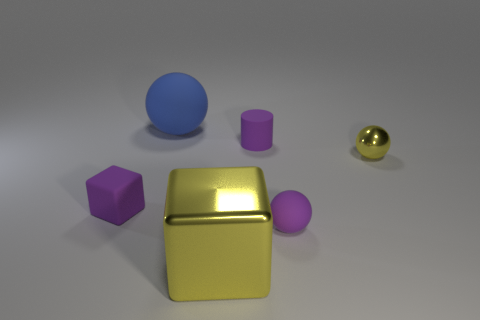Add 2 yellow things. How many objects exist? 8 Subtract all blocks. How many objects are left? 4 Subtract 0 green cubes. How many objects are left? 6 Subtract all small blue shiny objects. Subtract all small yellow metallic objects. How many objects are left? 5 Add 6 small purple matte spheres. How many small purple matte spheres are left? 7 Add 5 red metallic spheres. How many red metallic spheres exist? 5 